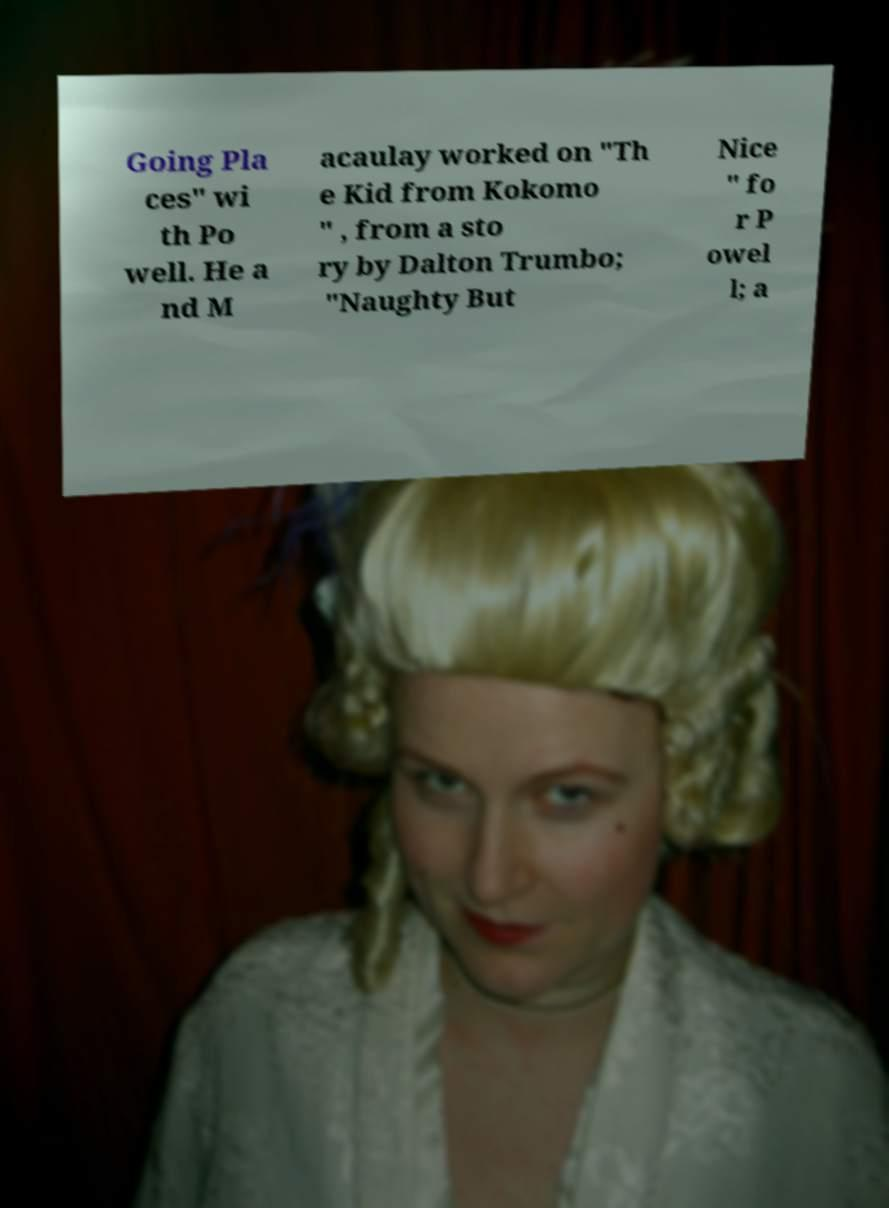Could you assist in decoding the text presented in this image and type it out clearly? Going Pla ces" wi th Po well. He a nd M acaulay worked on "Th e Kid from Kokomo " , from a sto ry by Dalton Trumbo; "Naughty But Nice " fo r P owel l; a 